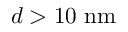Convert formula to latex. <formula><loc_0><loc_0><loc_500><loc_500>d > 1 0 n m</formula> 